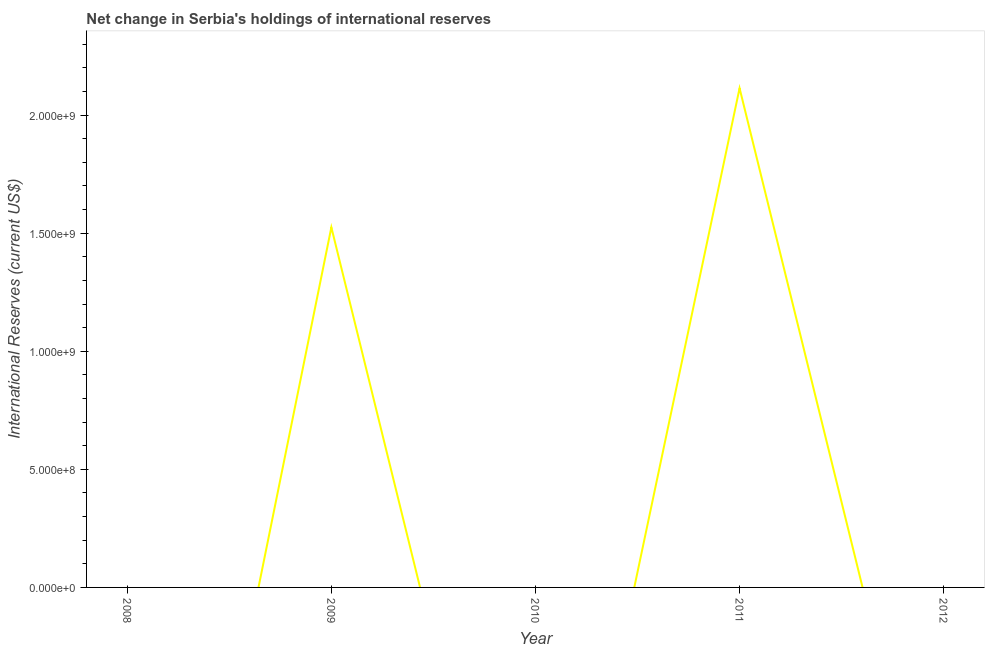What is the reserves and related items in 2009?
Offer a very short reply. 1.52e+09. Across all years, what is the maximum reserves and related items?
Offer a very short reply. 2.11e+09. What is the sum of the reserves and related items?
Provide a succinct answer. 3.64e+09. What is the difference between the reserves and related items in 2009 and 2011?
Your response must be concise. -5.89e+08. What is the average reserves and related items per year?
Provide a short and direct response. 7.28e+08. In how many years, is the reserves and related items greater than 200000000 US$?
Provide a short and direct response. 2. Is the difference between the reserves and related items in 2009 and 2011 greater than the difference between any two years?
Give a very brief answer. No. What is the difference between the highest and the lowest reserves and related items?
Ensure brevity in your answer.  2.11e+09. Does the reserves and related items monotonically increase over the years?
Keep it short and to the point. No. How many lines are there?
Your answer should be very brief. 1. How many years are there in the graph?
Offer a very short reply. 5. What is the title of the graph?
Ensure brevity in your answer.  Net change in Serbia's holdings of international reserves. What is the label or title of the X-axis?
Your answer should be very brief. Year. What is the label or title of the Y-axis?
Ensure brevity in your answer.  International Reserves (current US$). What is the International Reserves (current US$) in 2009?
Ensure brevity in your answer.  1.52e+09. What is the International Reserves (current US$) of 2011?
Give a very brief answer. 2.11e+09. What is the International Reserves (current US$) of 2012?
Your answer should be compact. 0. What is the difference between the International Reserves (current US$) in 2009 and 2011?
Provide a succinct answer. -5.89e+08. What is the ratio of the International Reserves (current US$) in 2009 to that in 2011?
Your response must be concise. 0.72. 